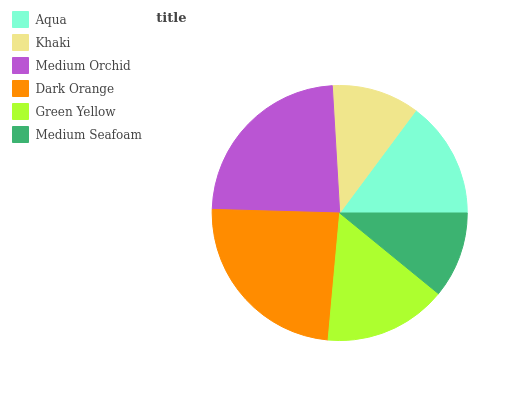Is Medium Seafoam the minimum?
Answer yes or no. Yes. Is Dark Orange the maximum?
Answer yes or no. Yes. Is Khaki the minimum?
Answer yes or no. No. Is Khaki the maximum?
Answer yes or no. No. Is Aqua greater than Khaki?
Answer yes or no. Yes. Is Khaki less than Aqua?
Answer yes or no. Yes. Is Khaki greater than Aqua?
Answer yes or no. No. Is Aqua less than Khaki?
Answer yes or no. No. Is Green Yellow the high median?
Answer yes or no. Yes. Is Aqua the low median?
Answer yes or no. Yes. Is Aqua the high median?
Answer yes or no. No. Is Dark Orange the low median?
Answer yes or no. No. 